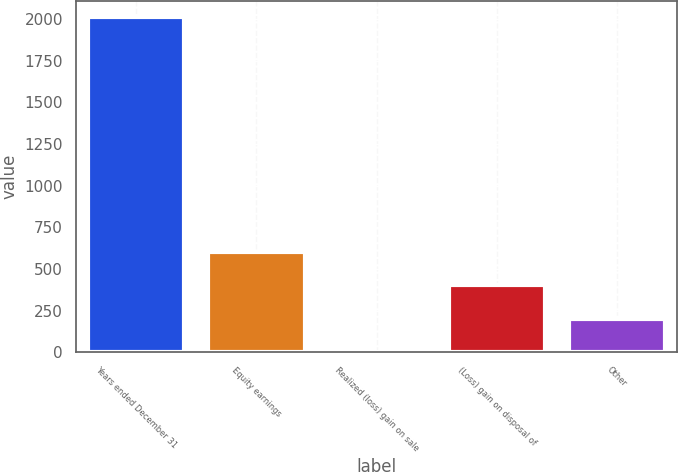<chart> <loc_0><loc_0><loc_500><loc_500><bar_chart><fcel>Years ended December 31<fcel>Equity earnings<fcel>Realized (loss) gain on sale<fcel>(Loss) gain on disposal of<fcel>Other<nl><fcel>2009<fcel>603.4<fcel>1<fcel>402.6<fcel>201.8<nl></chart> 